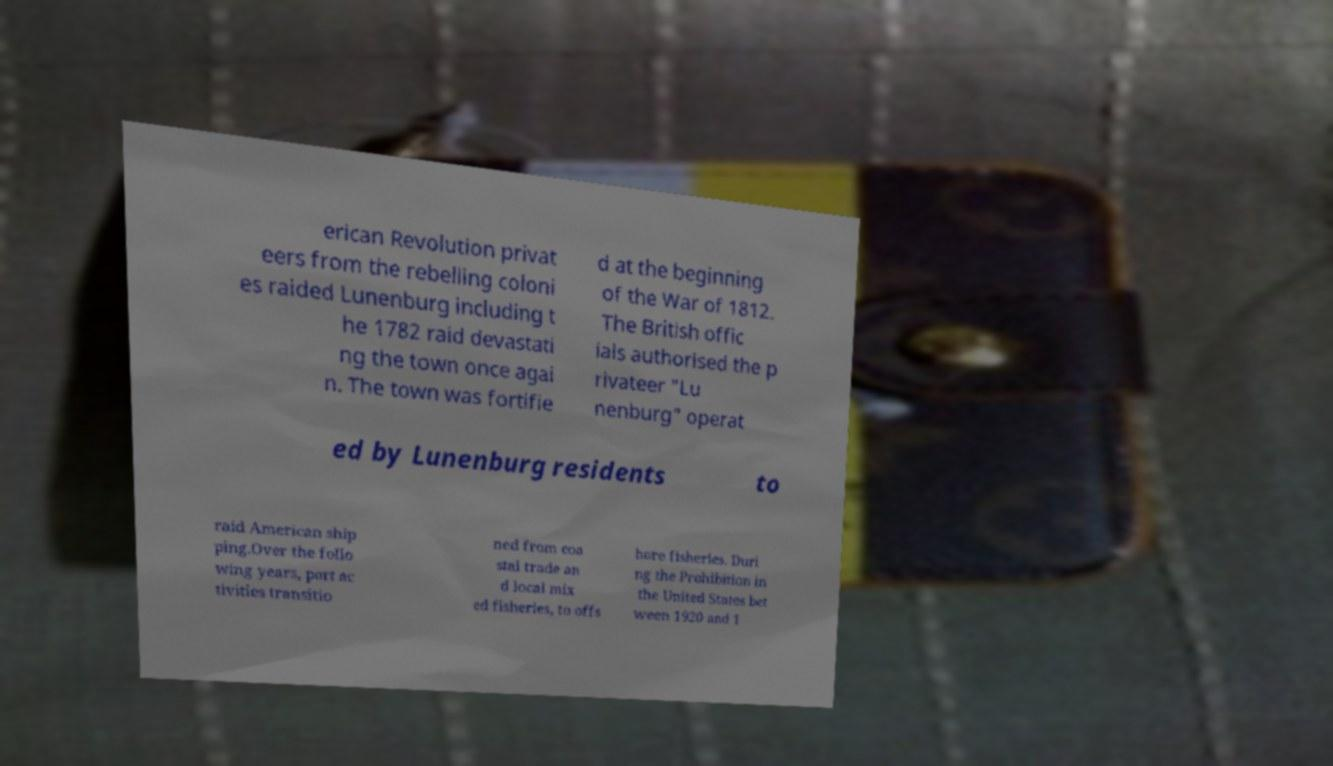Please identify and transcribe the text found in this image. erican Revolution privat eers from the rebelling coloni es raided Lunenburg including t he 1782 raid devastati ng the town once agai n. The town was fortifie d at the beginning of the War of 1812. The British offic ials authorised the p rivateer "Lu nenburg" operat ed by Lunenburg residents to raid American ship ping.Over the follo wing years, port ac tivities transitio ned from coa stal trade an d local mix ed fisheries, to offs hore fisheries. Duri ng the Prohibition in the United States bet ween 1920 and 1 